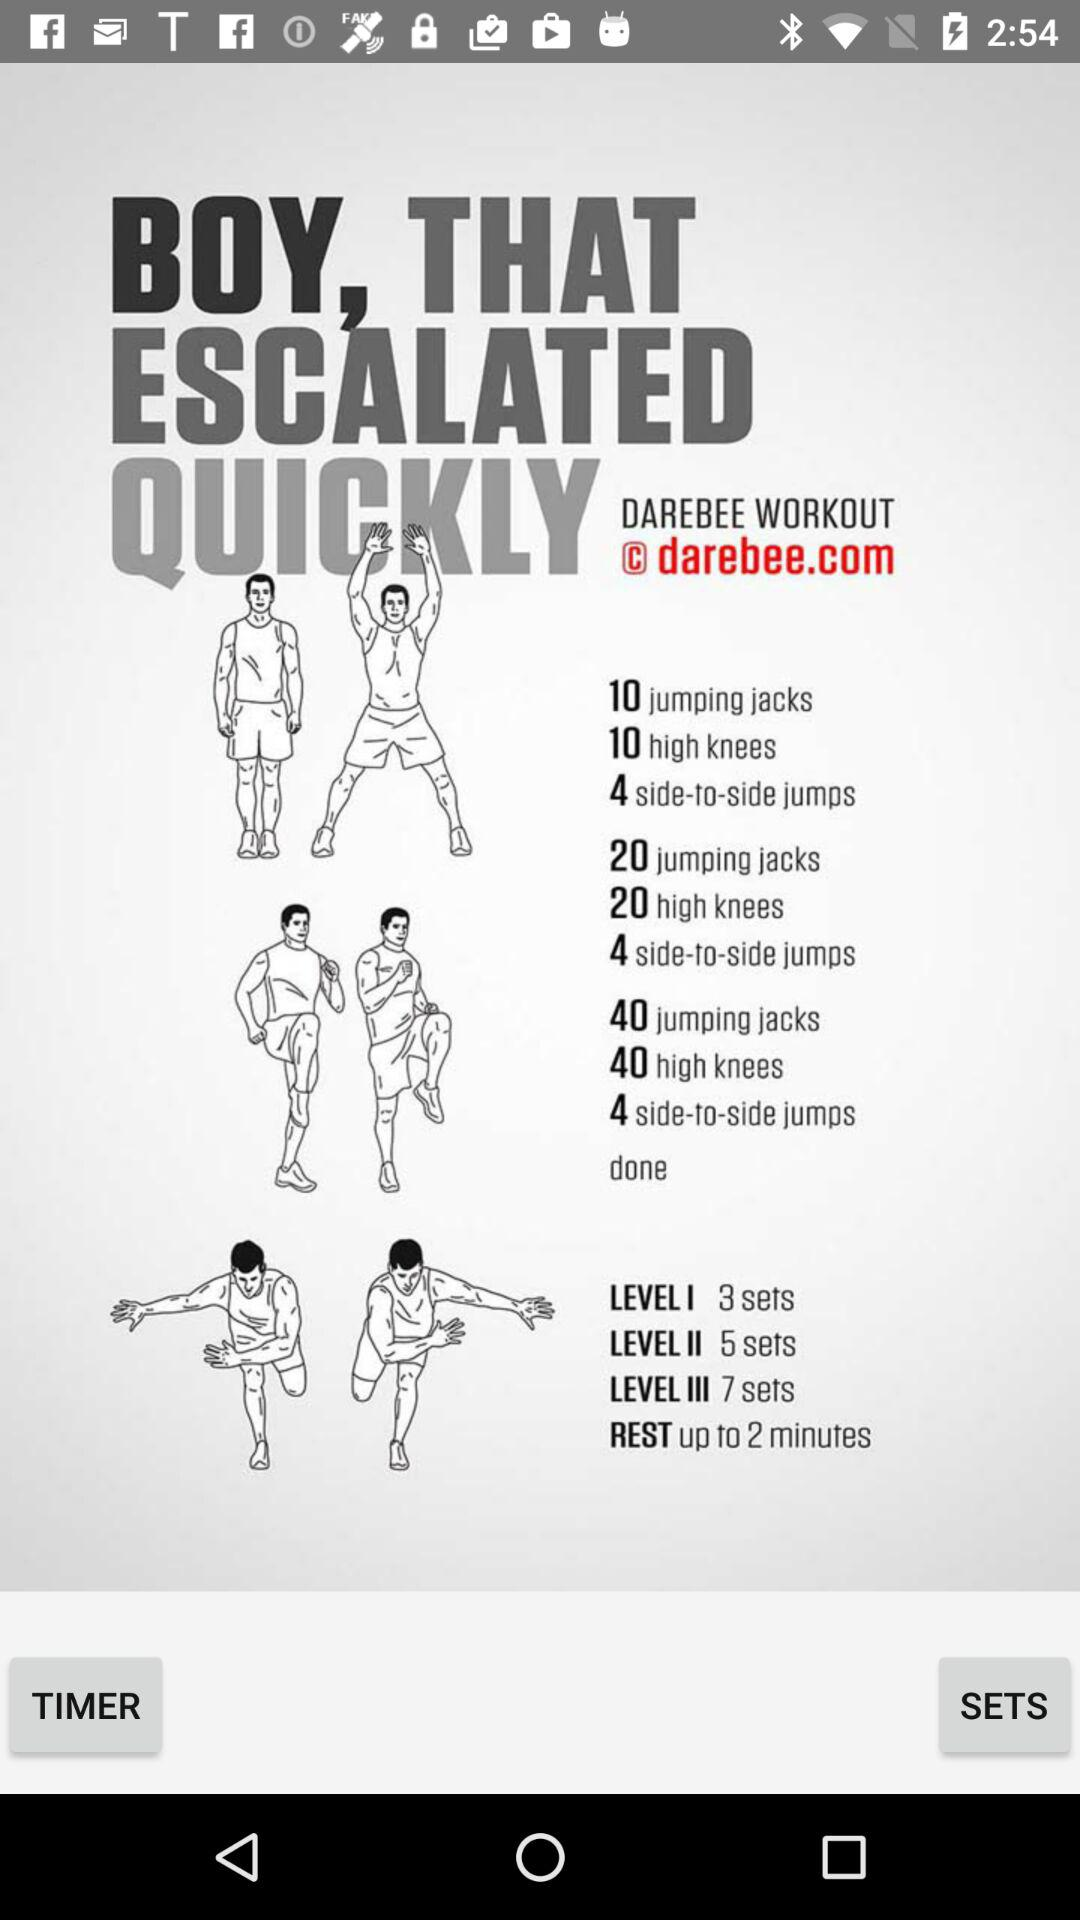How much time is there for the rest? The rest time is up to 2 minutes. 